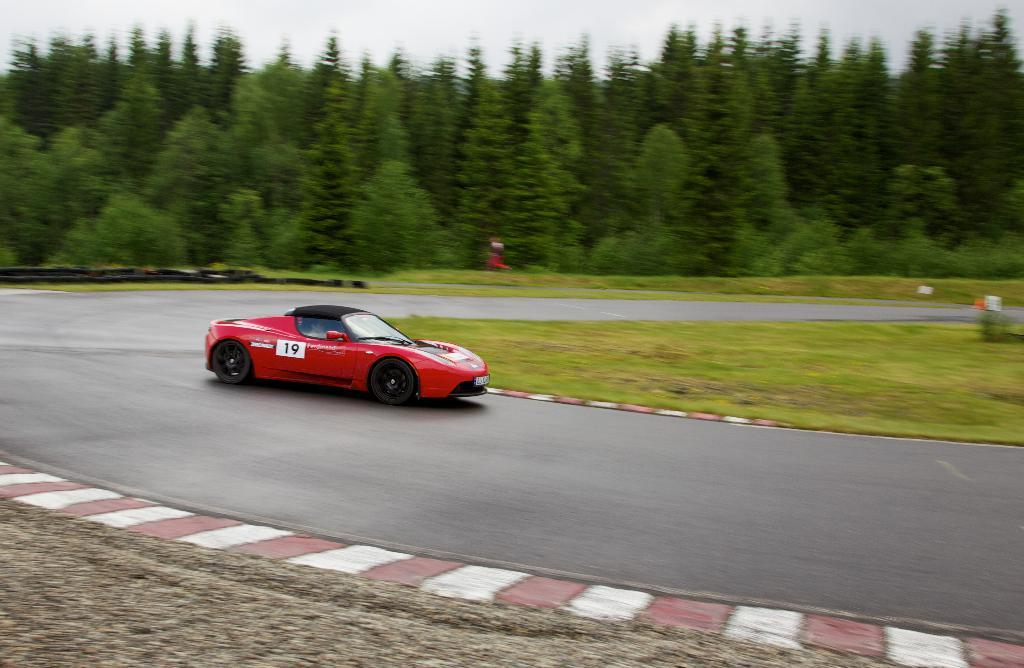What is the main subject of the image? There is a car on the road in the image. What type of vegetation can be seen in the image? There is grass visible in the image, and there is a group of trees as well. What is the condition of the sky in the image? The sky is visible in the image and appears cloudy. Can you tell me how many grapes are hanging from the trees in the image? There are no grapes visible in the image; the trees are not fruit-bearing trees. What type of footwear is the pig wearing in the image? There is no pig present in the image, so it is not possible to determine what type of footwear it might be wearing. 